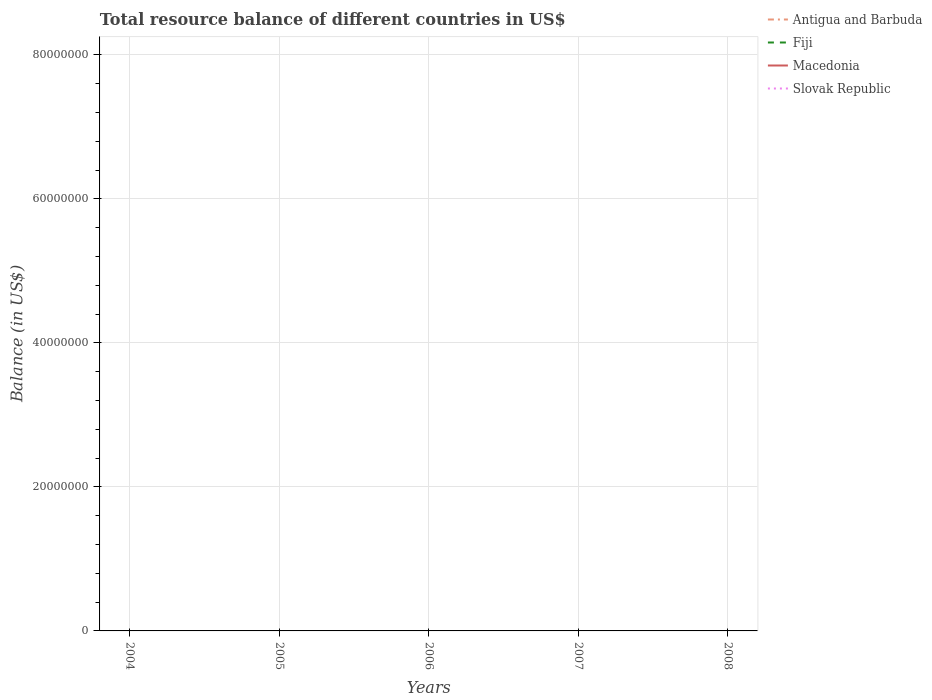Does the line corresponding to Antigua and Barbuda intersect with the line corresponding to Fiji?
Provide a succinct answer. No. Is the number of lines equal to the number of legend labels?
Your response must be concise. No. Across all years, what is the maximum total resource balance in Fiji?
Offer a very short reply. 0. What is the difference between the highest and the lowest total resource balance in Slovak Republic?
Offer a terse response. 0. How many lines are there?
Offer a terse response. 0. What is the difference between two consecutive major ticks on the Y-axis?
Give a very brief answer. 2.00e+07. Are the values on the major ticks of Y-axis written in scientific E-notation?
Your answer should be very brief. No. Where does the legend appear in the graph?
Your answer should be compact. Top right. How many legend labels are there?
Ensure brevity in your answer.  4. How are the legend labels stacked?
Your answer should be very brief. Vertical. What is the title of the graph?
Offer a very short reply. Total resource balance of different countries in US$. What is the label or title of the Y-axis?
Give a very brief answer. Balance (in US$). What is the Balance (in US$) in Antigua and Barbuda in 2004?
Ensure brevity in your answer.  0. What is the Balance (in US$) in Fiji in 2004?
Offer a terse response. 0. What is the Balance (in US$) of Antigua and Barbuda in 2006?
Provide a succinct answer. 0. What is the Balance (in US$) in Macedonia in 2007?
Provide a short and direct response. 0. What is the Balance (in US$) in Antigua and Barbuda in 2008?
Provide a short and direct response. 0. What is the Balance (in US$) of Macedonia in 2008?
Keep it short and to the point. 0. What is the Balance (in US$) in Slovak Republic in 2008?
Provide a succinct answer. 0. What is the total Balance (in US$) of Antigua and Barbuda in the graph?
Your answer should be very brief. 0. What is the total Balance (in US$) in Macedonia in the graph?
Offer a terse response. 0. What is the average Balance (in US$) of Antigua and Barbuda per year?
Offer a terse response. 0. What is the average Balance (in US$) in Slovak Republic per year?
Your answer should be compact. 0. 